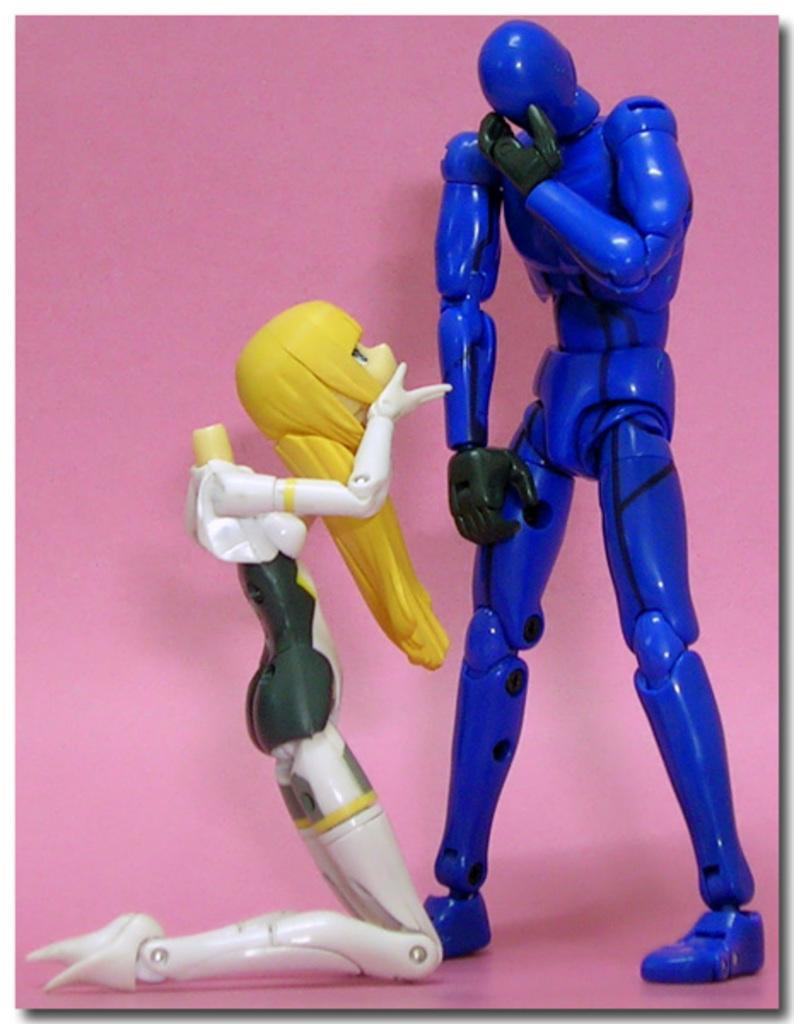Could you give a brief overview of what you see in this image? In this image we can see two toys placed on the surface. 